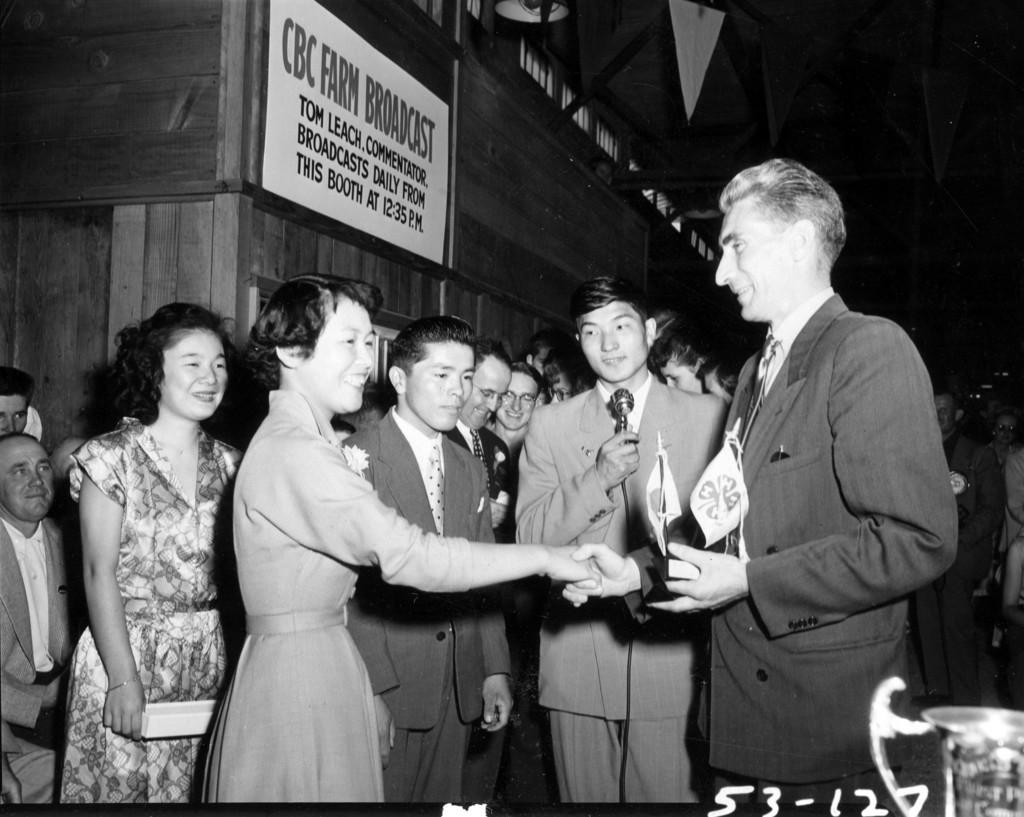What is the color scheme of the image? The image is black and white. What is happening between the man and the woman in the image? The man is congratulating the woman in the image. Can you describe the background of the image? There are people in the background of the image, and there is a wooden wall. What type of cake is being served in the image? There is no cake present in the image; it is a black and white image of a man congratulating a woman with people and a wooden wall in the background. 